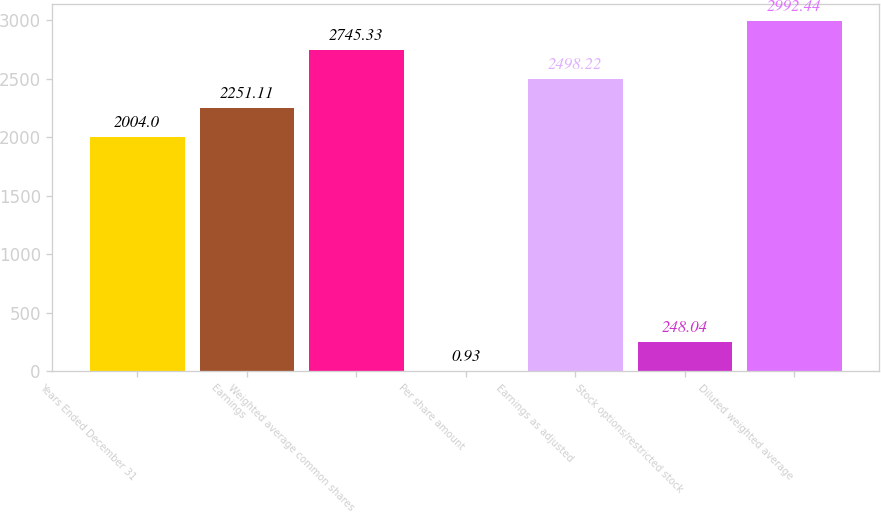<chart> <loc_0><loc_0><loc_500><loc_500><bar_chart><fcel>Years Ended December 31<fcel>Earnings<fcel>Weighted average common shares<fcel>Per share amount<fcel>Earnings as adjusted<fcel>Stock options/restricted stock<fcel>Diluted weighted average<nl><fcel>2004<fcel>2251.11<fcel>2745.33<fcel>0.93<fcel>2498.22<fcel>248.04<fcel>2992.44<nl></chart> 